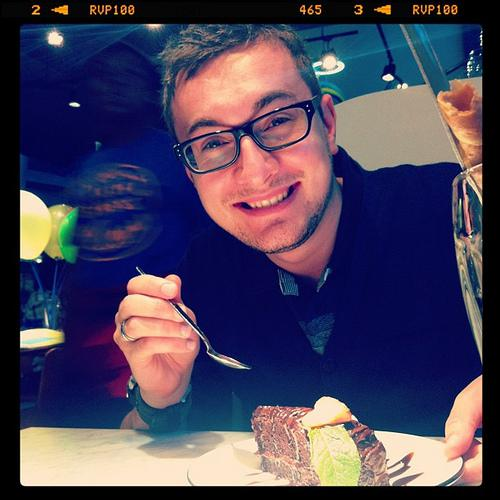Question: what is yellow in the background?
Choices:
A. Sun.
B. Balloons.
C. Flowers.
D. Car.
Answer with the letter. Answer: B Question: where was this picture taken?
Choices:
A. In a museum.
B. At a Restaurant.
C. At the movies.
D. In a theater.
Answer with the letter. Answer: B Question: how is the man eating the cake?
Choices:
A. With a fork.
B. With a spoon.
C. Picking it up.
D. Knife.
Answer with the letter. Answer: B Question: who is in the background?
Choices:
A. A woman.
B. A man.
C. A child.
D. A dog.
Answer with the letter. Answer: B Question: what is the color of the man's shirt?
Choices:
A. Black.
B. Blue.
C. Green.
D. Red.
Answer with the letter. Answer: A 